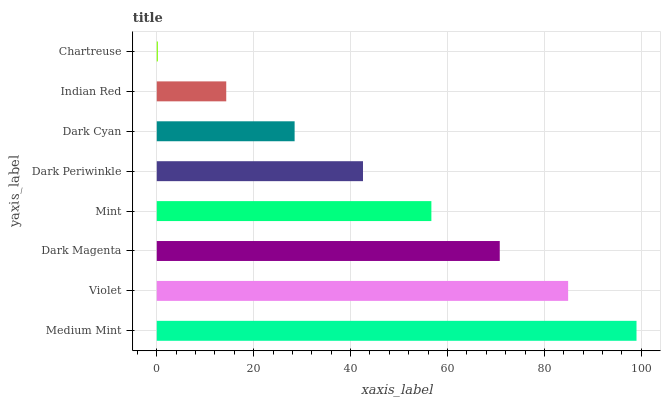Is Chartreuse the minimum?
Answer yes or no. Yes. Is Medium Mint the maximum?
Answer yes or no. Yes. Is Violet the minimum?
Answer yes or no. No. Is Violet the maximum?
Answer yes or no. No. Is Medium Mint greater than Violet?
Answer yes or no. Yes. Is Violet less than Medium Mint?
Answer yes or no. Yes. Is Violet greater than Medium Mint?
Answer yes or no. No. Is Medium Mint less than Violet?
Answer yes or no. No. Is Mint the high median?
Answer yes or no. Yes. Is Dark Periwinkle the low median?
Answer yes or no. Yes. Is Dark Cyan the high median?
Answer yes or no. No. Is Chartreuse the low median?
Answer yes or no. No. 